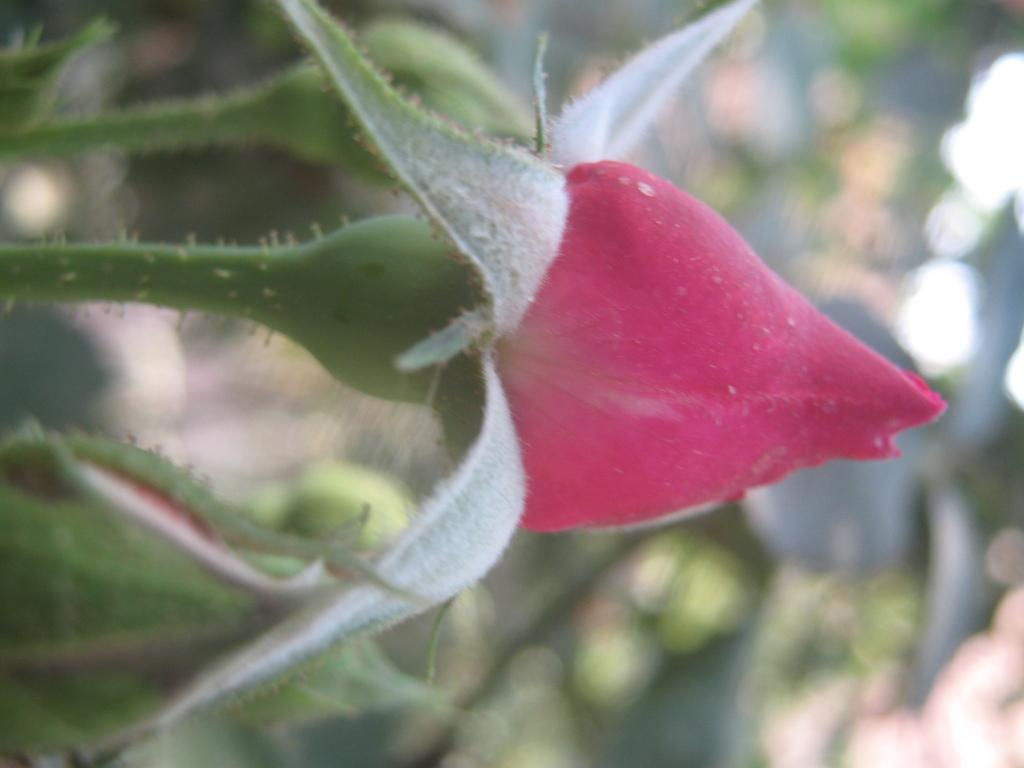What type of plant parts can be seen in the image? There are buds and stems in the image. Can you describe the background of the image? The background of the image is blurred. What type of ball is being used by the porter in the image? There is no ball or porter present in the image. Can you see the ear of the person in the image? There is no person present in the image, so it is not possible to see their ear. 